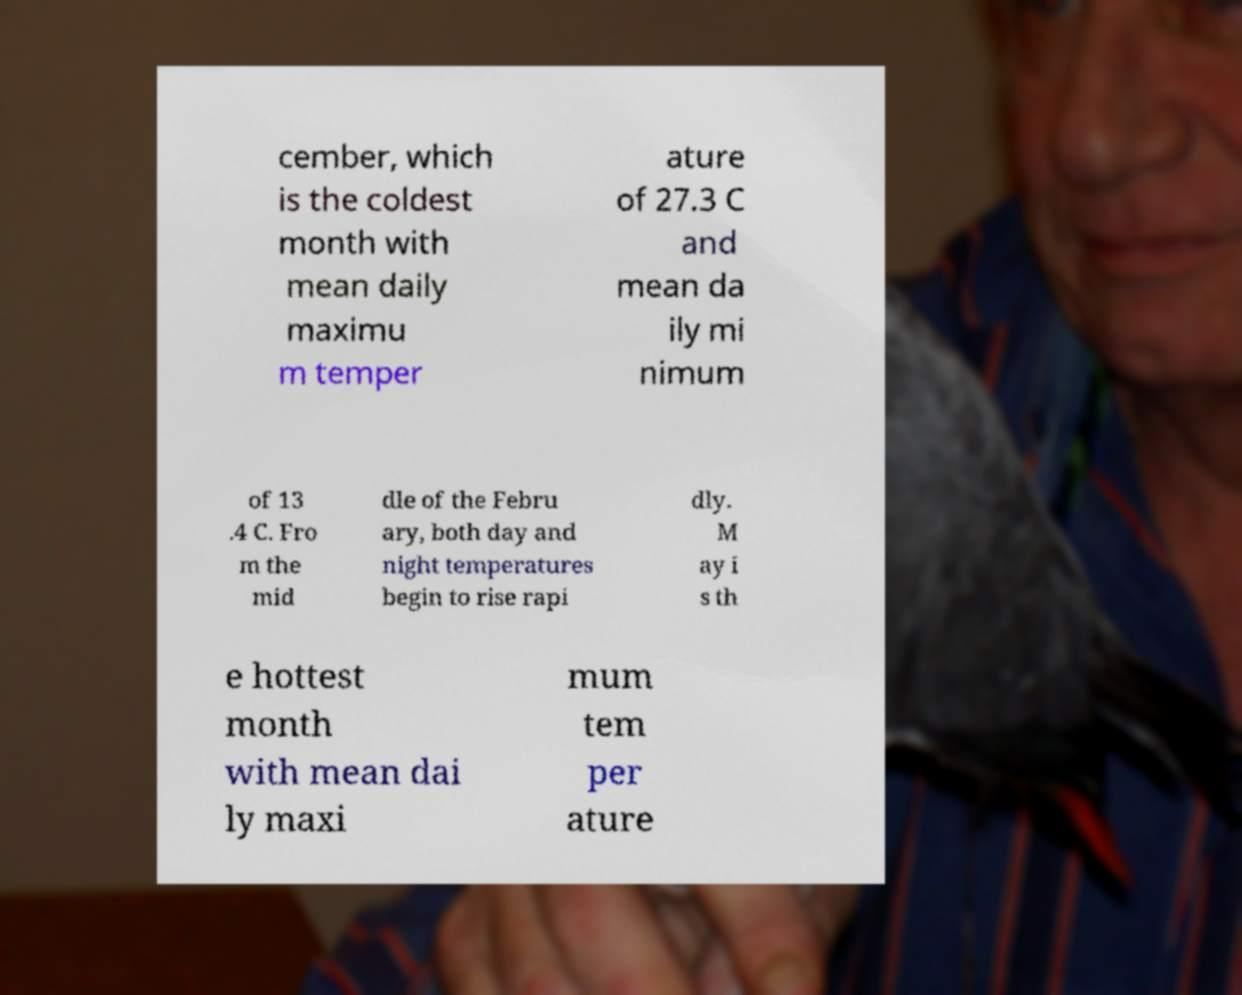For documentation purposes, I need the text within this image transcribed. Could you provide that? cember, which is the coldest month with mean daily maximu m temper ature of 27.3 C and mean da ily mi nimum of 13 .4 C. Fro m the mid dle of the Febru ary, both day and night temperatures begin to rise rapi dly. M ay i s th e hottest month with mean dai ly maxi mum tem per ature 